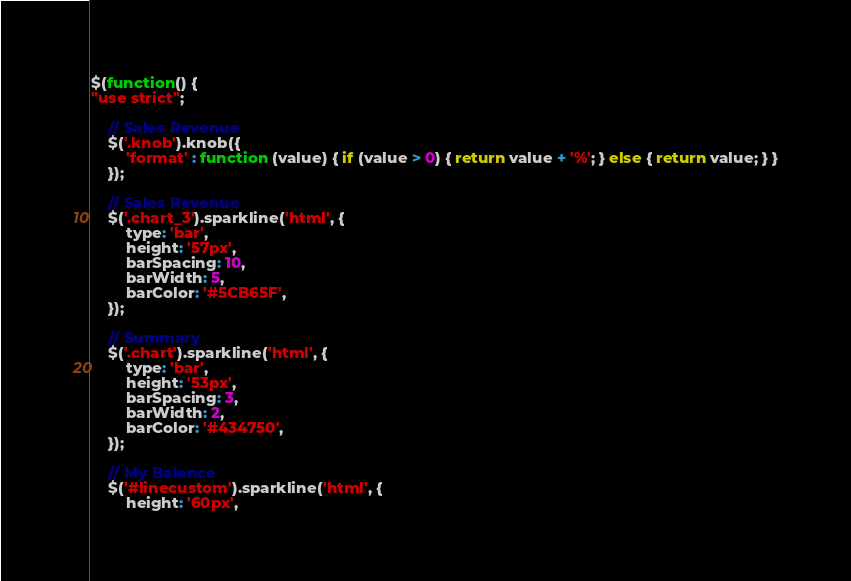Convert code to text. <code><loc_0><loc_0><loc_500><loc_500><_JavaScript_>$(function() {
"use strict";

    // Sales Revenue 
    $('.knob').knob({ 
        'format' : function (value) { if (value > 0) { return value + '%'; } else { return value; } }
    });

    // Sales Revenue
    $('.chart_3').sparkline('html', {
        type: 'bar',
        height: '57px',
        barSpacing: 10,
        barWidth: 5,
        barColor: '#5CB65F',        
    });

    // Summary 
    $('.chart').sparkline('html', {
        type: 'bar',
        height: '53px',
        barSpacing: 3,
        barWidth: 2,
        barColor: '#434750',        
    });    

    // My Balance
    $('#linecustom').sparkline('html', {
        height: '60px',</code> 